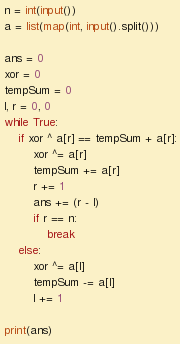<code> <loc_0><loc_0><loc_500><loc_500><_Python_>n = int(input())
a = list(map(int, input().split()))

ans = 0
xor = 0
tempSum = 0
l, r = 0, 0
while True:
    if xor ^ a[r] == tempSum + a[r]:
        xor ^= a[r]
        tempSum += a[r]
        r += 1
        ans += (r - l)
        if r == n:
            break
    else:
        xor ^= a[l]
        tempSum -= a[l]
        l += 1

print(ans)
</code> 